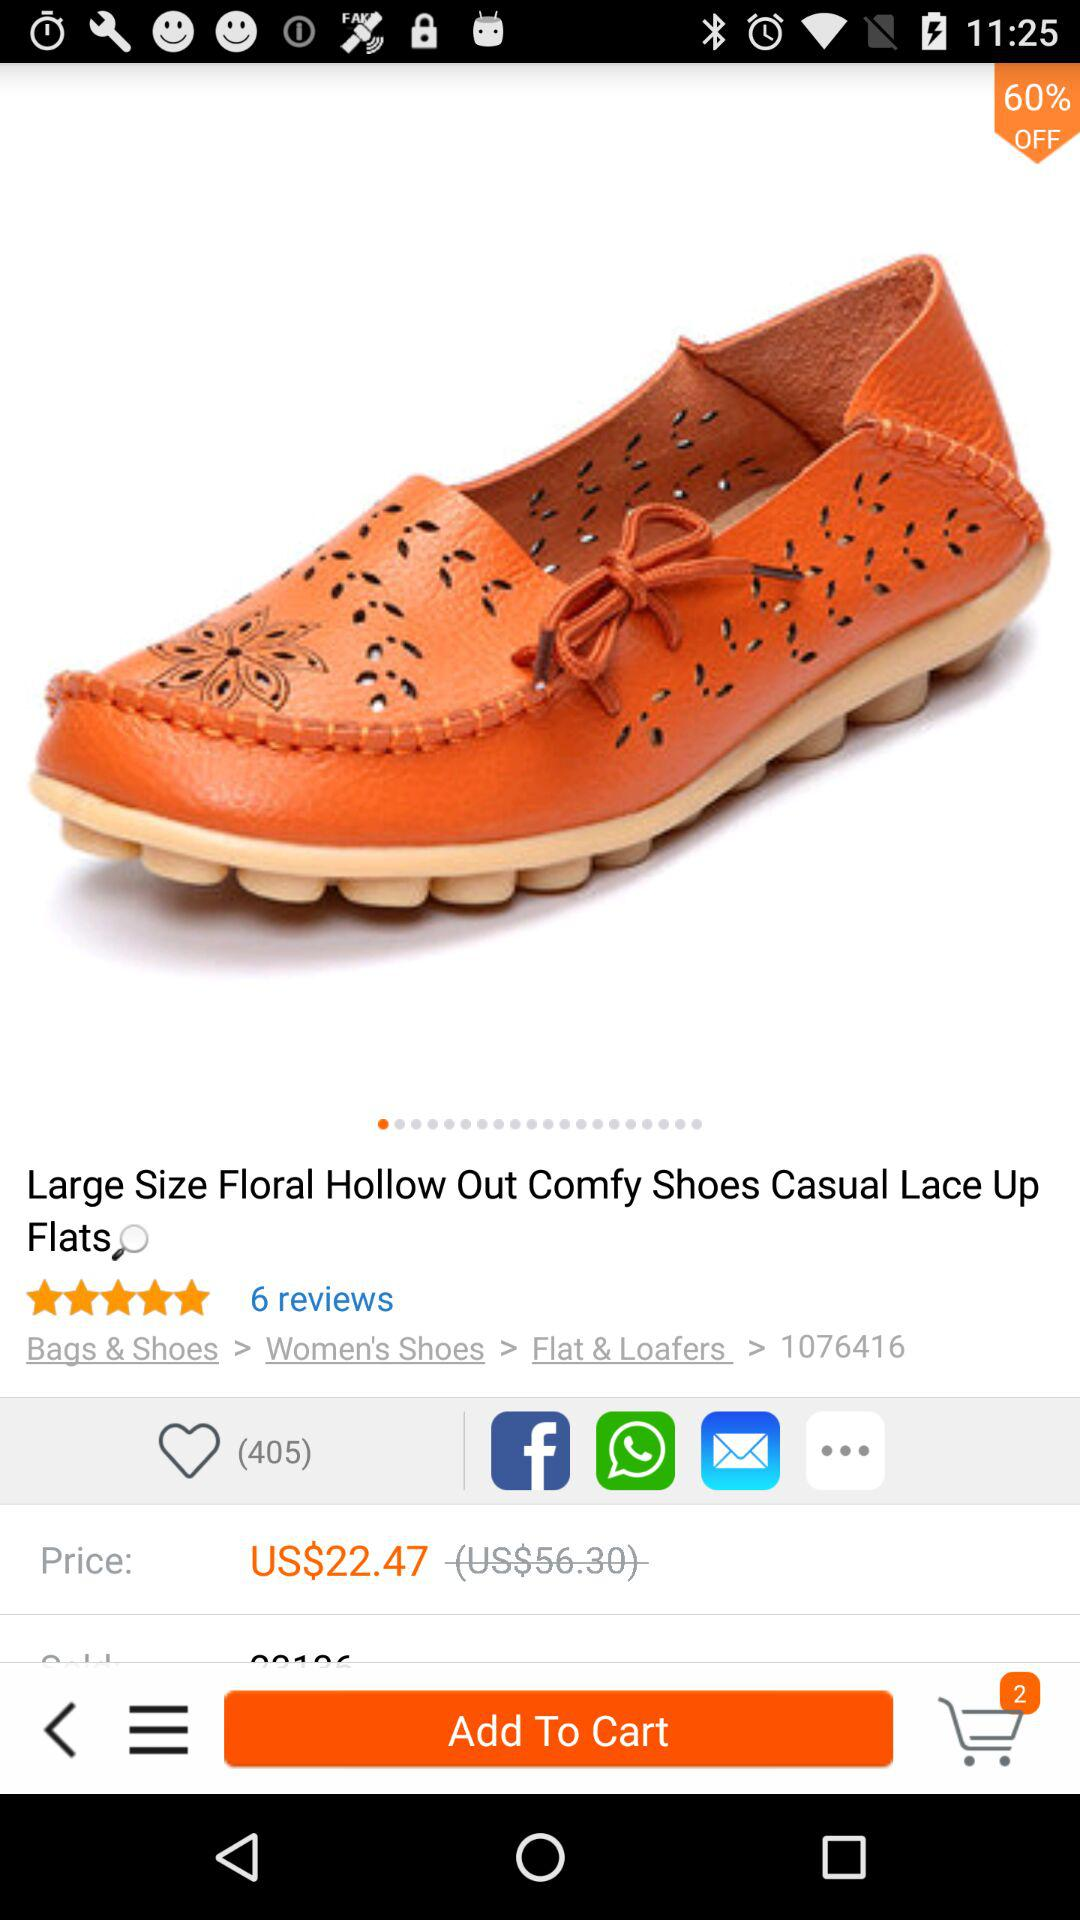How much is the product after the discount?
Answer the question using a single word or phrase. US$22.47 